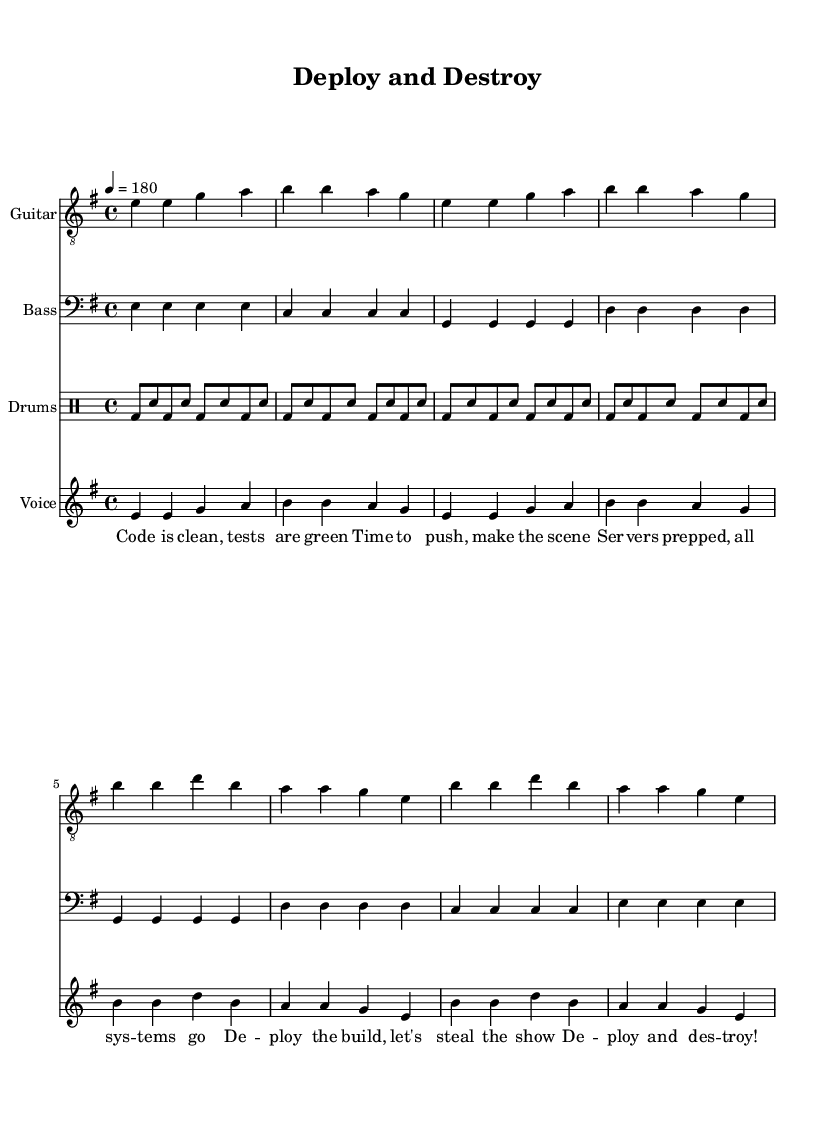What is the key signature of this music? The key signature is E minor, which has one sharp (F#). This can be identified by looking at the key signature section located at the beginning of the staff.
Answer: E minor What is the time signature of this sheet music? The time signature is 4/4, indicated by the numbers at the beginning of the music. This means there are four beats per measure and the quarter note gets one beat.
Answer: 4/4 What is the tempo marking for this piece? The tempo is marked at 180 beats per minute, specified by the notation “\tempo 4 = 180” at the beginning of the score. This indicates the speed of the music.
Answer: 180 How many measures are there in the verse? The verse consists of four measures, which can be counted by looking at the section labeled as "Verse" in the music. Each group of notes ending with a bar line represents one measure.
Answer: 4 What instruments are included in this piece? The piece includes Guitar, Bass, Drums, and Vocals. This information can be found at the start of each staff in the score, where the instrument names are listed.
Answer: Guitar, Bass, Drums, Vocals What theme is celebrated in the lyrics of this punk anthem? The lyrics celebrate successful software deployments, emphasizing themes of clean code and bug-free releases. This can be understood by analyzing the content of the verse and chorus lyrics written beneath the music.
Answer: Successful software deployments What type of musical structure is used in this punk anthem? The structure used involves alternating verses and choruses, a common structure in punk anthems that helps to create an energetic and repetitive style. This can be inferred by looking at how the lyrics are divided in the score.
Answer: Verse and Chorus 